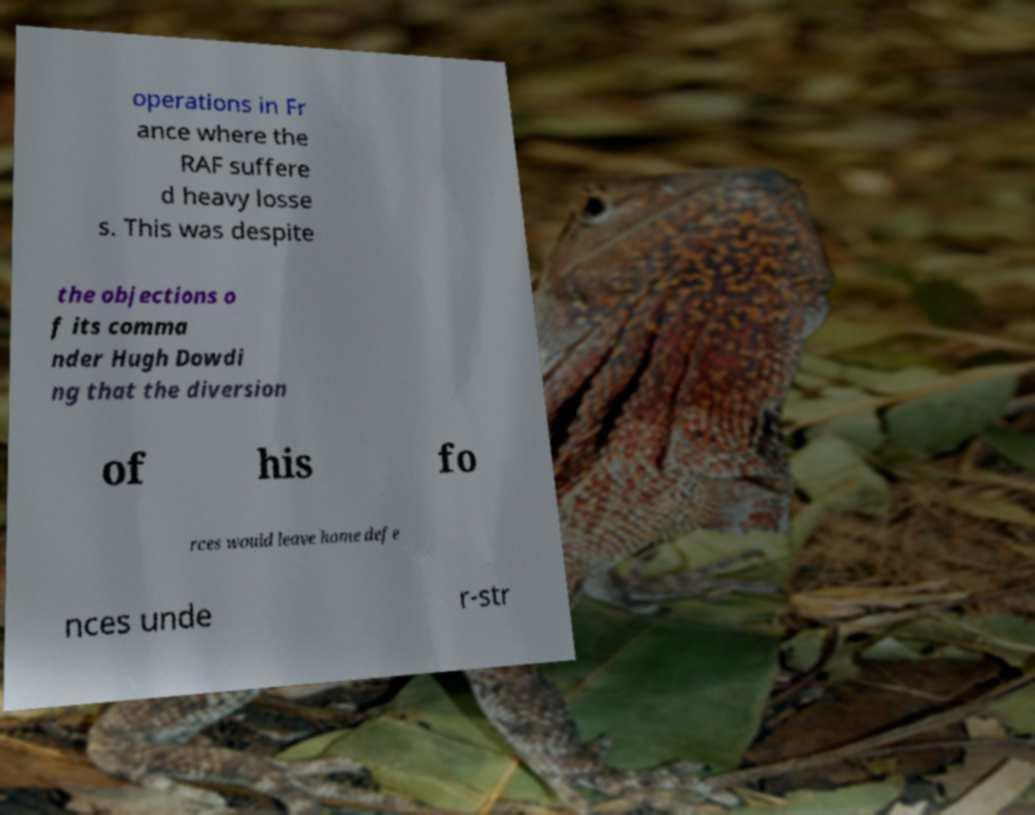There's text embedded in this image that I need extracted. Can you transcribe it verbatim? operations in Fr ance where the RAF suffere d heavy losse s. This was despite the objections o f its comma nder Hugh Dowdi ng that the diversion of his fo rces would leave home defe nces unde r-str 